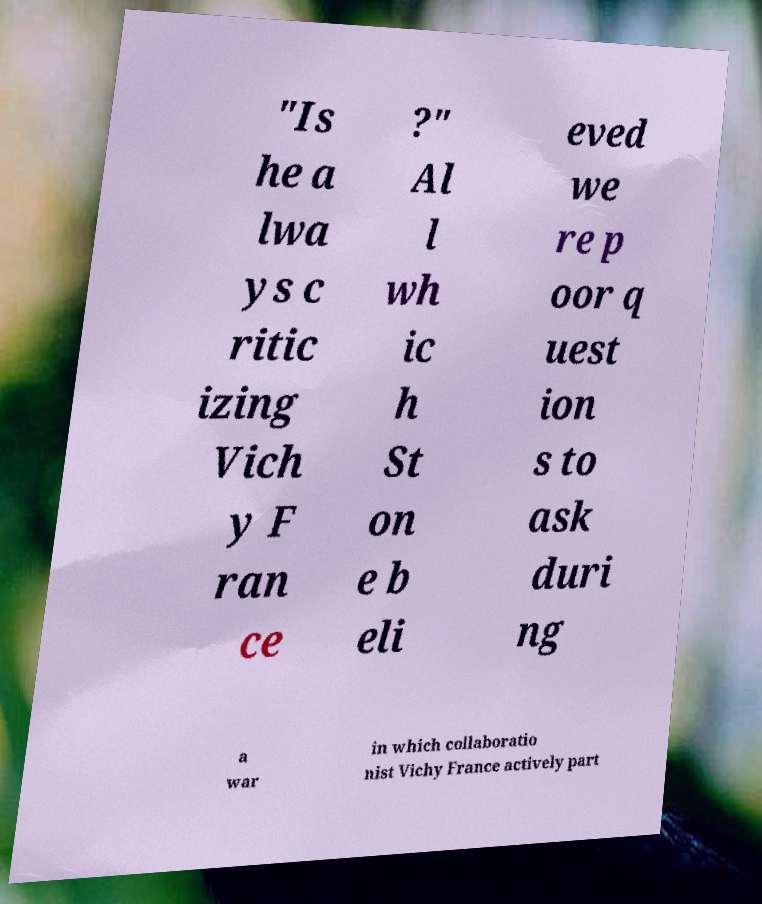What messages or text are displayed in this image? I need them in a readable, typed format. "Is he a lwa ys c ritic izing Vich y F ran ce ?" Al l wh ic h St on e b eli eved we re p oor q uest ion s to ask duri ng a war in which collaboratio nist Vichy France actively part 